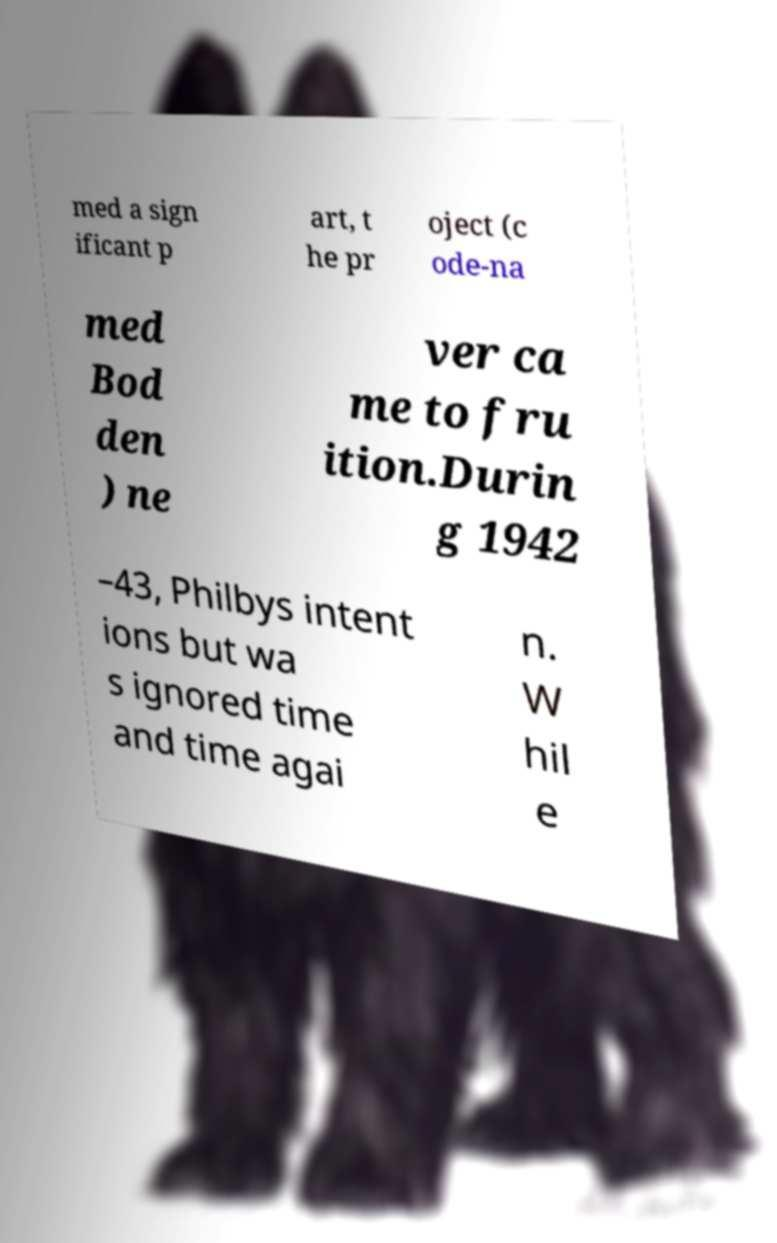Could you extract and type out the text from this image? med a sign ificant p art, t he pr oject (c ode-na med Bod den ) ne ver ca me to fru ition.Durin g 1942 –43, Philbys intent ions but wa s ignored time and time agai n. W hil e 